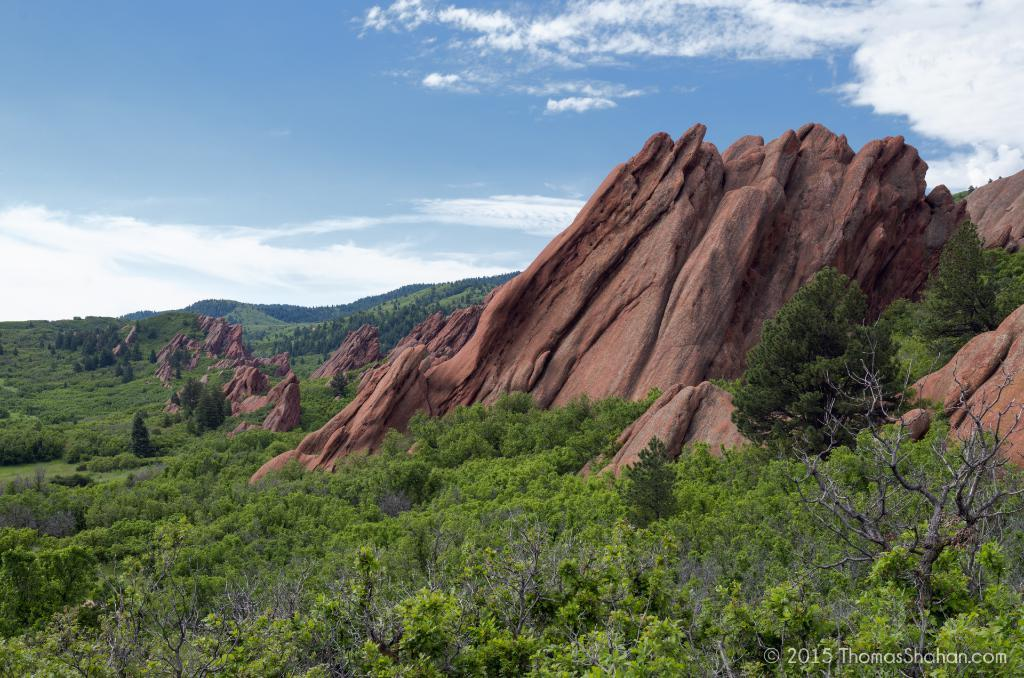What type of living organisms can be seen in the image? Plants can be seen in the image. What type of natural elements are present in the image? Brown color rocks are present in the image. What can be seen in the background of the image? Clouds and the sky are visible in the background of the image. What type of silk can be seen hanging from the plants in the image? There is no silk present in the image; it features plants and rocks. Can you identify any fangs on the plants in the image? There are no fangs present on the plants in the image; they are simply plants. 